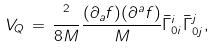<formula> <loc_0><loc_0><loc_500><loc_500>V _ { Q } \, = \, \frac { { } ^ { 2 } } { 8 M } \frac { ( \partial _ { a } f ) ( \partial ^ { a } f ) } { M } { \bar { \Gamma } } _ { 0 i } ^ { i } { \bar { \Gamma } } _ { 0 j } ^ { j } ,</formula> 